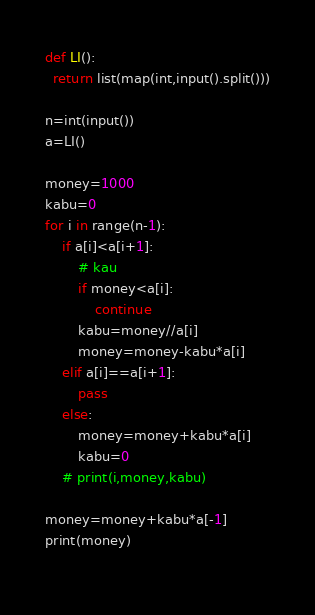<code> <loc_0><loc_0><loc_500><loc_500><_Python_>def LI():
  return list(map(int,input().split()))
  
n=int(input())
a=LI()

money=1000
kabu=0
for i in range(n-1):
    if a[i]<a[i+1]:
        # kau
        if money<a[i]:
            continue
        kabu=money//a[i]
        money=money-kabu*a[i]
    elif a[i]==a[i+1]:
        pass
    else:
        money=money+kabu*a[i]
        kabu=0
    # print(i,money,kabu)

money=money+kabu*a[-1]
print(money)
    </code> 